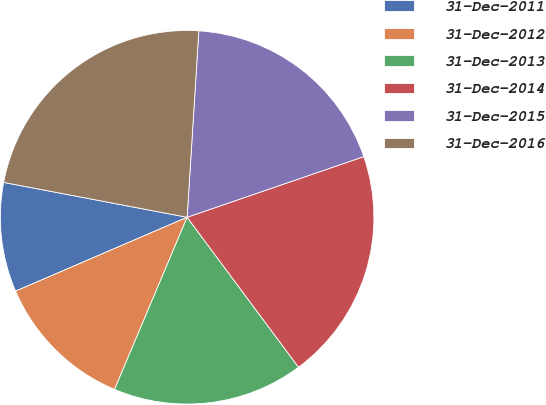Convert chart. <chart><loc_0><loc_0><loc_500><loc_500><pie_chart><fcel>31-Dec-2011<fcel>31-Dec-2012<fcel>31-Dec-2013<fcel>31-Dec-2014<fcel>31-Dec-2015<fcel>31-Dec-2016<nl><fcel>9.46%<fcel>12.18%<fcel>16.52%<fcel>20.1%<fcel>18.74%<fcel>23.01%<nl></chart> 